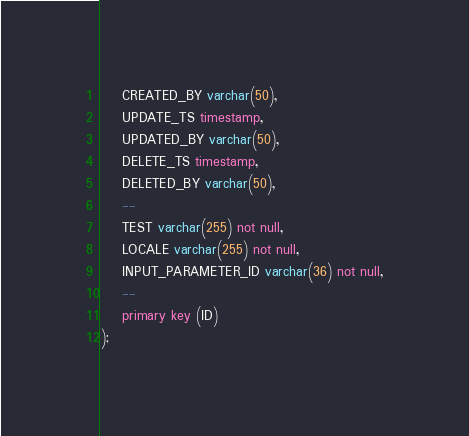<code> <loc_0><loc_0><loc_500><loc_500><_SQL_>    CREATED_BY varchar(50),
    UPDATE_TS timestamp,
    UPDATED_BY varchar(50),
    DELETE_TS timestamp,
    DELETED_BY varchar(50),
    --
    TEST varchar(255) not null,
    LOCALE varchar(255) not null,
    INPUT_PARAMETER_ID varchar(36) not null,
    --
    primary key (ID)
);</code> 